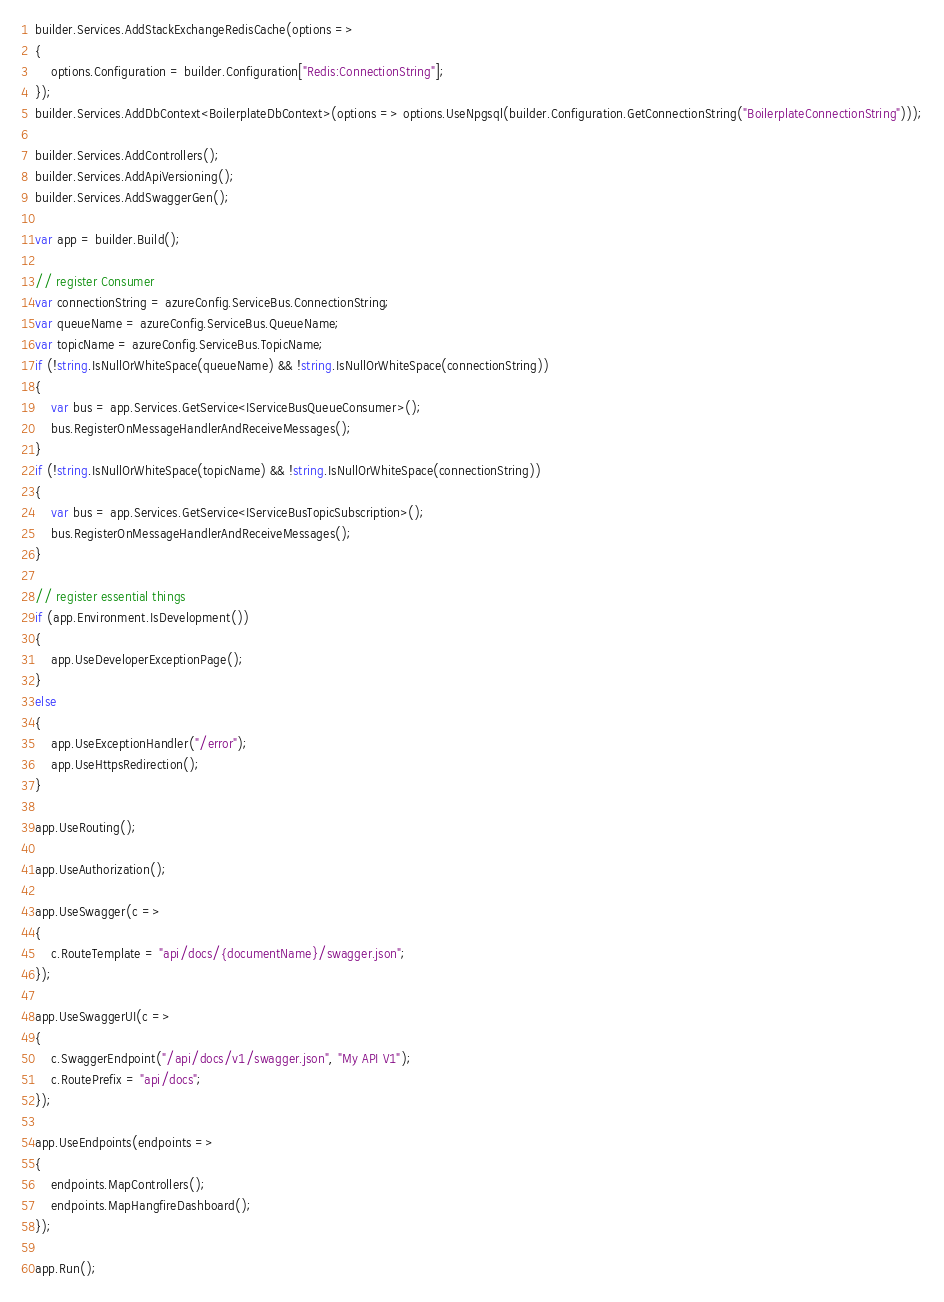<code> <loc_0><loc_0><loc_500><loc_500><_C#_>builder.Services.AddStackExchangeRedisCache(options =>
{
    options.Configuration = builder.Configuration["Redis:ConnectionString"];
});
builder.Services.AddDbContext<BoilerplateDbContext>(options => options.UseNpgsql(builder.Configuration.GetConnectionString("BoilerplateConnectionString")));

builder.Services.AddControllers();
builder.Services.AddApiVersioning();
builder.Services.AddSwaggerGen();

var app = builder.Build();

// register Consumer
var connectionString = azureConfig.ServiceBus.ConnectionString;
var queueName = azureConfig.ServiceBus.QueueName;
var topicName = azureConfig.ServiceBus.TopicName;
if (!string.IsNullOrWhiteSpace(queueName) && !string.IsNullOrWhiteSpace(connectionString))
{
    var bus = app.Services.GetService<IServiceBusQueueConsumer>();
    bus.RegisterOnMessageHandlerAndReceiveMessages();
}
if (!string.IsNullOrWhiteSpace(topicName) && !string.IsNullOrWhiteSpace(connectionString))
{
    var bus = app.Services.GetService<IServiceBusTopicSubscription>();
    bus.RegisterOnMessageHandlerAndReceiveMessages();
}

// register essential things
if (app.Environment.IsDevelopment())
{
    app.UseDeveloperExceptionPage();
}
else
{
    app.UseExceptionHandler("/error");
    app.UseHttpsRedirection();
}

app.UseRouting();

app.UseAuthorization();

app.UseSwagger(c =>
{
    c.RouteTemplate = "api/docs/{documentName}/swagger.json";
});

app.UseSwaggerUI(c =>
{
    c.SwaggerEndpoint("/api/docs/v1/swagger.json", "My API V1");
    c.RoutePrefix = "api/docs";
});

app.UseEndpoints(endpoints =>
{
    endpoints.MapControllers();
    endpoints.MapHangfireDashboard();
});

app.Run();
</code> 